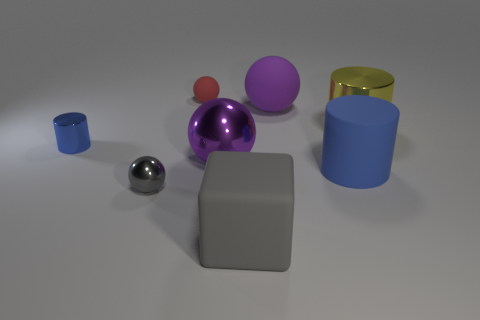Subtract all big cylinders. How many cylinders are left? 1 Subtract all cubes. How many objects are left? 7 Subtract all yellow cylinders. How many cylinders are left? 2 Add 2 big yellow cylinders. How many objects exist? 10 Subtract 1 cylinders. How many cylinders are left? 2 Subtract all small purple rubber cylinders. Subtract all small rubber balls. How many objects are left? 7 Add 7 tiny red matte objects. How many tiny red matte objects are left? 8 Add 3 blocks. How many blocks exist? 4 Subtract 0 green blocks. How many objects are left? 8 Subtract all cyan blocks. Subtract all blue balls. How many blocks are left? 1 